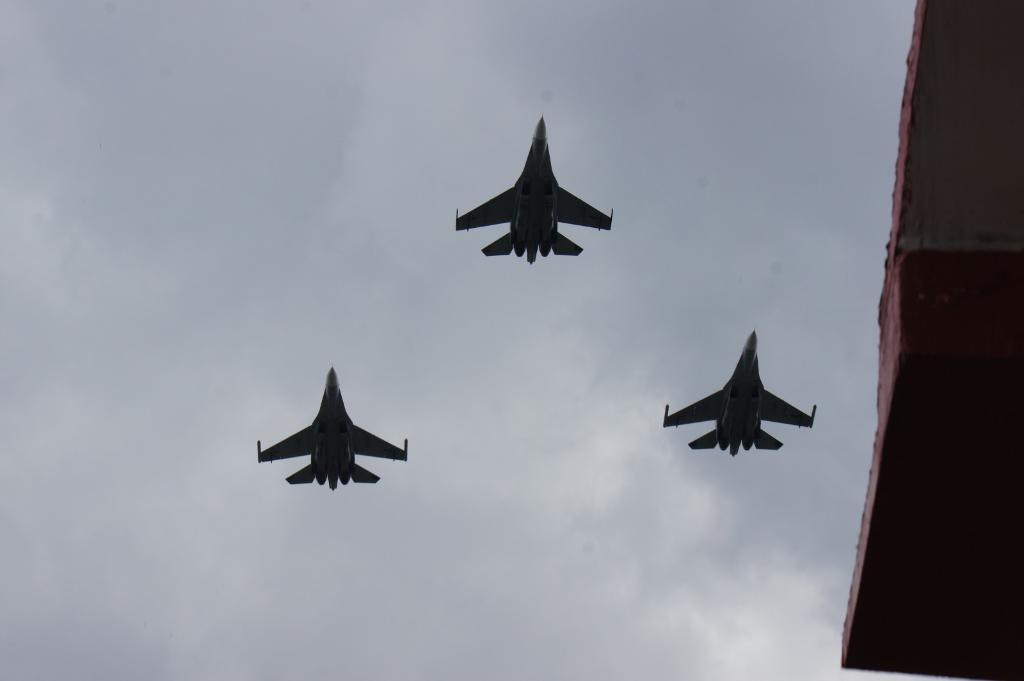What is happening in the image? There are airplanes flying in the image. What structure can be seen on the right side of the image? There is a building on the right side of the image. What part of the natural environment is visible in the image? The sky is visible in the image. What type of skate is being used by the person on the ground in the image? There is no person on the ground using a skate in the image; it only features airplanes flying and a building on the right side. What book is the person reading in the image? There is no person reading a book in the image; it only features airplanes flying and a building on the right side. 